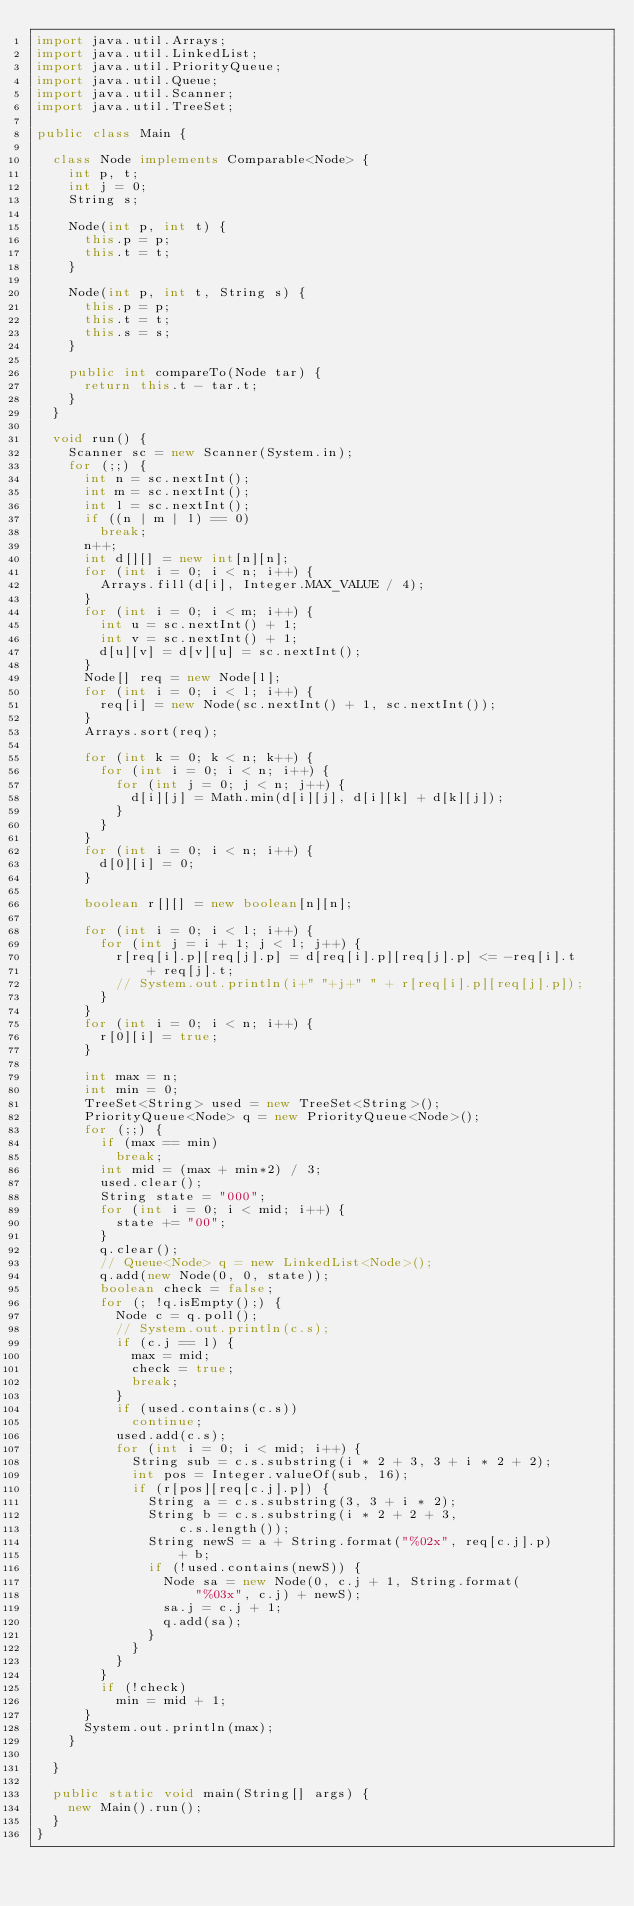<code> <loc_0><loc_0><loc_500><loc_500><_Java_>import java.util.Arrays;
import java.util.LinkedList;
import java.util.PriorityQueue;
import java.util.Queue;
import java.util.Scanner;
import java.util.TreeSet;

public class Main {

	class Node implements Comparable<Node> {
		int p, t;
		int j = 0;
		String s;

		Node(int p, int t) {
			this.p = p;
			this.t = t;
		}

		Node(int p, int t, String s) {
			this.p = p;
			this.t = t;
			this.s = s;
		}

		public int compareTo(Node tar) {
			return this.t - tar.t;
		}
	}

	void run() {
		Scanner sc = new Scanner(System.in);
		for (;;) {
			int n = sc.nextInt();
			int m = sc.nextInt();
			int l = sc.nextInt();
			if ((n | m | l) == 0)
				break;
			n++;
			int d[][] = new int[n][n];
			for (int i = 0; i < n; i++) {
				Arrays.fill(d[i], Integer.MAX_VALUE / 4);
			}
			for (int i = 0; i < m; i++) {
				int u = sc.nextInt() + 1;
				int v = sc.nextInt() + 1;
				d[u][v] = d[v][u] = sc.nextInt();
			}
			Node[] req = new Node[l];
			for (int i = 0; i < l; i++) {
				req[i] = new Node(sc.nextInt() + 1, sc.nextInt());
			}
			Arrays.sort(req);

			for (int k = 0; k < n; k++) {
				for (int i = 0; i < n; i++) {
					for (int j = 0; j < n; j++) {
						d[i][j] = Math.min(d[i][j], d[i][k] + d[k][j]);
					}
				}
			}
			for (int i = 0; i < n; i++) {
				d[0][i] = 0;
			}

			boolean r[][] = new boolean[n][n];

			for (int i = 0; i < l; i++) {
				for (int j = i + 1; j < l; j++) {
					r[req[i].p][req[j].p] = d[req[i].p][req[j].p] <= -req[i].t
							+ req[j].t;
					// System.out.println(i+" "+j+" " + r[req[i].p][req[j].p]);
				}
			}
			for (int i = 0; i < n; i++) {
				r[0][i] = true;
			}

			int max = n;
			int min = 0;
			TreeSet<String> used = new TreeSet<String>();
			PriorityQueue<Node> q = new PriorityQueue<Node>();
			for (;;) {
				if (max == min)
					break;
				int mid = (max + min*2) / 3;
				used.clear();
				String state = "000";
				for (int i = 0; i < mid; i++) {
					state += "00";
				}
				q.clear();
				// Queue<Node> q = new LinkedList<Node>();
				q.add(new Node(0, 0, state));
				boolean check = false;
				for (; !q.isEmpty();) {
					Node c = q.poll();
					// System.out.println(c.s);
					if (c.j == l) {
						max = mid;
						check = true;
						break;
					}
					if (used.contains(c.s))
						continue;
					used.add(c.s);
					for (int i = 0; i < mid; i++) {
						String sub = c.s.substring(i * 2 + 3, 3 + i * 2 + 2);
						int pos = Integer.valueOf(sub, 16);
						if (r[pos][req[c.j].p]) {
							String a = c.s.substring(3, 3 + i * 2);
							String b = c.s.substring(i * 2 + 2 + 3,
									c.s.length());
							String newS = a + String.format("%02x", req[c.j].p)
									+ b;
							if (!used.contains(newS)) {
								Node sa = new Node(0, c.j + 1, String.format(
										"%03x", c.j) + newS);
								sa.j = c.j + 1;
								q.add(sa);
							}
						}
					}
				}
				if (!check)
					min = mid + 1;
			}
			System.out.println(max);
		}

	}

	public static void main(String[] args) {
		new Main().run();
	}
}</code> 